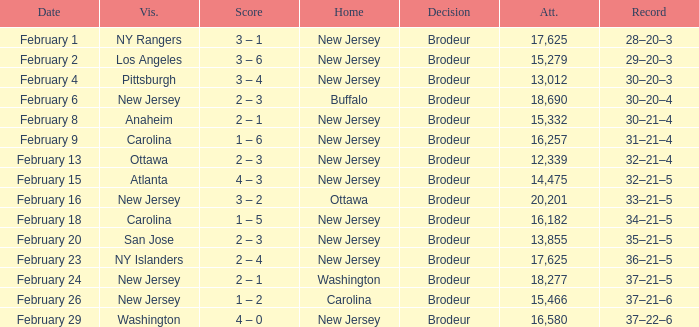What was the record when the visiting team was Ottawa? 32–21–4. 